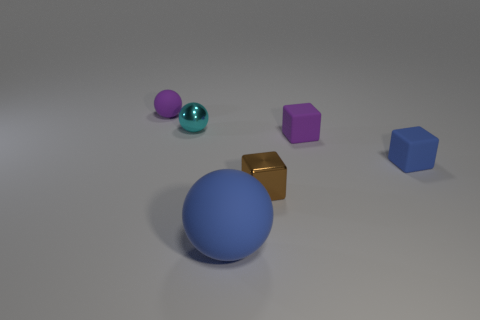Subtract all small balls. How many balls are left? 1 Subtract all purple spheres. How many spheres are left? 2 Add 3 green cylinders. How many green cylinders exist? 3 Add 4 tiny blue metal cylinders. How many objects exist? 10 Subtract 0 red blocks. How many objects are left? 6 Subtract 2 blocks. How many blocks are left? 1 Subtract all red blocks. Subtract all gray cylinders. How many blocks are left? 3 Subtract all purple spheres. How many purple cubes are left? 1 Subtract all yellow shiny things. Subtract all small purple rubber spheres. How many objects are left? 5 Add 1 small brown metallic objects. How many small brown metallic objects are left? 2 